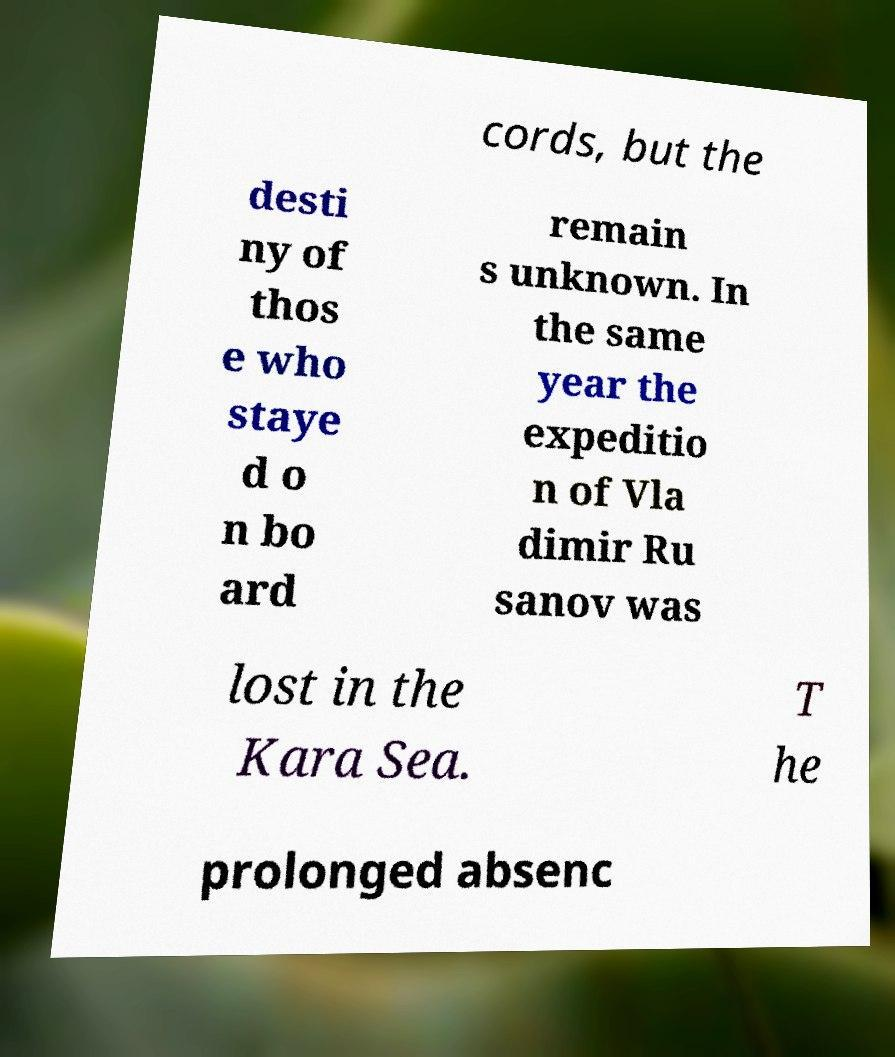Can you read and provide the text displayed in the image?This photo seems to have some interesting text. Can you extract and type it out for me? cords, but the desti ny of thos e who staye d o n bo ard remain s unknown. In the same year the expeditio n of Vla dimir Ru sanov was lost in the Kara Sea. T he prolonged absenc 